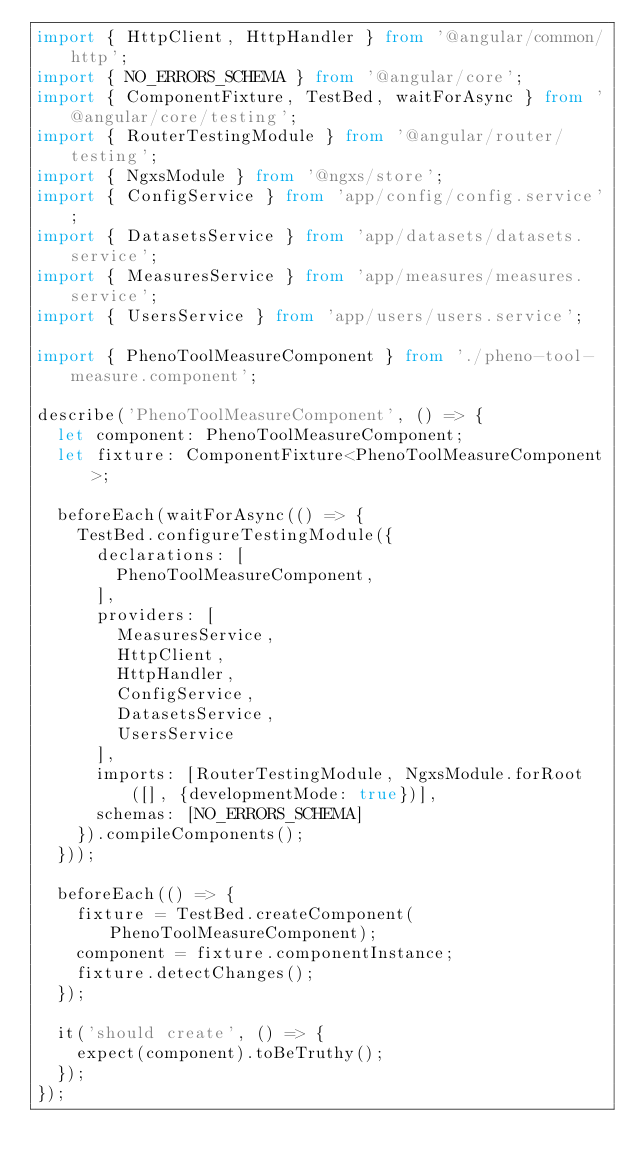Convert code to text. <code><loc_0><loc_0><loc_500><loc_500><_TypeScript_>import { HttpClient, HttpHandler } from '@angular/common/http';
import { NO_ERRORS_SCHEMA } from '@angular/core';
import { ComponentFixture, TestBed, waitForAsync } from '@angular/core/testing';
import { RouterTestingModule } from '@angular/router/testing';
import { NgxsModule } from '@ngxs/store';
import { ConfigService } from 'app/config/config.service';
import { DatasetsService } from 'app/datasets/datasets.service';
import { MeasuresService } from 'app/measures/measures.service';
import { UsersService } from 'app/users/users.service';

import { PhenoToolMeasureComponent } from './pheno-tool-measure.component';

describe('PhenoToolMeasureComponent', () => {
  let component: PhenoToolMeasureComponent;
  let fixture: ComponentFixture<PhenoToolMeasureComponent>;

  beforeEach(waitForAsync(() => {
    TestBed.configureTestingModule({
      declarations: [
        PhenoToolMeasureComponent,
      ],
      providers: [
        MeasuresService,
        HttpClient,
        HttpHandler,
        ConfigService,
        DatasetsService,
        UsersService
      ],
      imports: [RouterTestingModule, NgxsModule.forRoot([], {developmentMode: true})],
      schemas: [NO_ERRORS_SCHEMA]
    }).compileComponents();
  }));

  beforeEach(() => {
    fixture = TestBed.createComponent(PhenoToolMeasureComponent);
    component = fixture.componentInstance;
    fixture.detectChanges();
  });

  it('should create', () => {
    expect(component).toBeTruthy();
  });
});
</code> 